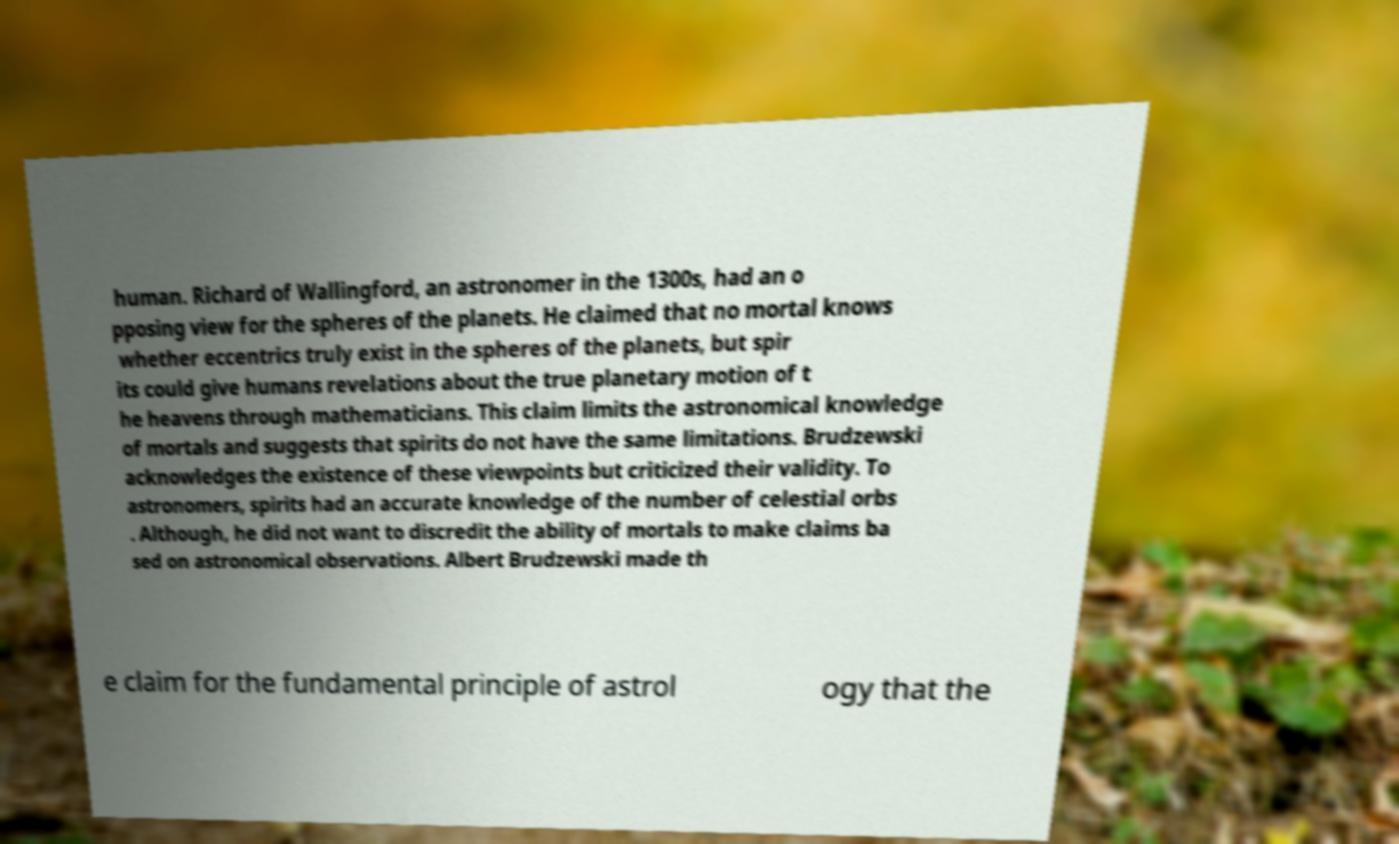For documentation purposes, I need the text within this image transcribed. Could you provide that? human. Richard of Wallingford, an astronomer in the 1300s, had an o pposing view for the spheres of the planets. He claimed that no mortal knows whether eccentrics truly exist in the spheres of the planets, but spir its could give humans revelations about the true planetary motion of t he heavens through mathematicians. This claim limits the astronomical knowledge of mortals and suggests that spirits do not have the same limitations. Brudzewski acknowledges the existence of these viewpoints but criticized their validity. To astronomers, spirits had an accurate knowledge of the number of celestial orbs . Although, he did not want to discredit the ability of mortals to make claims ba sed on astronomical observations. Albert Brudzewski made th e claim for the fundamental principle of astrol ogy that the 